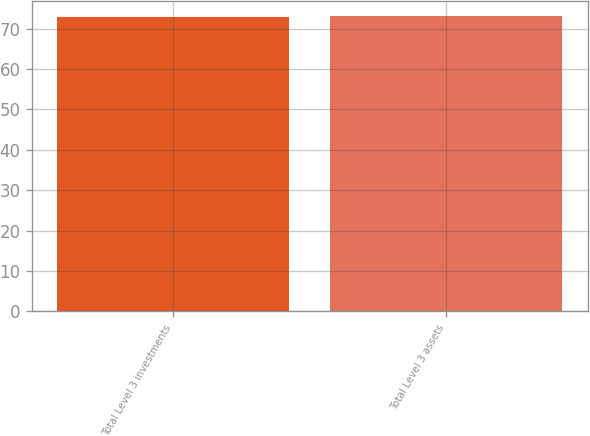Convert chart to OTSL. <chart><loc_0><loc_0><loc_500><loc_500><bar_chart><fcel>Total Level 3 investments<fcel>Total Level 3 assets<nl><fcel>73<fcel>73.1<nl></chart> 